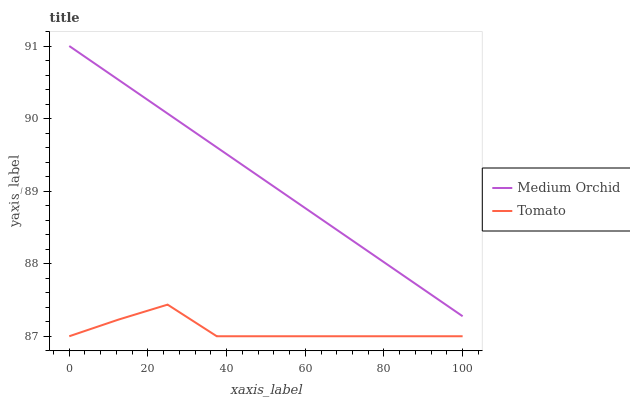Does Tomato have the minimum area under the curve?
Answer yes or no. Yes. Does Medium Orchid have the maximum area under the curve?
Answer yes or no. Yes. Does Medium Orchid have the minimum area under the curve?
Answer yes or no. No. Is Medium Orchid the smoothest?
Answer yes or no. Yes. Is Tomato the roughest?
Answer yes or no. Yes. Is Medium Orchid the roughest?
Answer yes or no. No. Does Medium Orchid have the lowest value?
Answer yes or no. No. Does Medium Orchid have the highest value?
Answer yes or no. Yes. Is Tomato less than Medium Orchid?
Answer yes or no. Yes. Is Medium Orchid greater than Tomato?
Answer yes or no. Yes. Does Tomato intersect Medium Orchid?
Answer yes or no. No. 